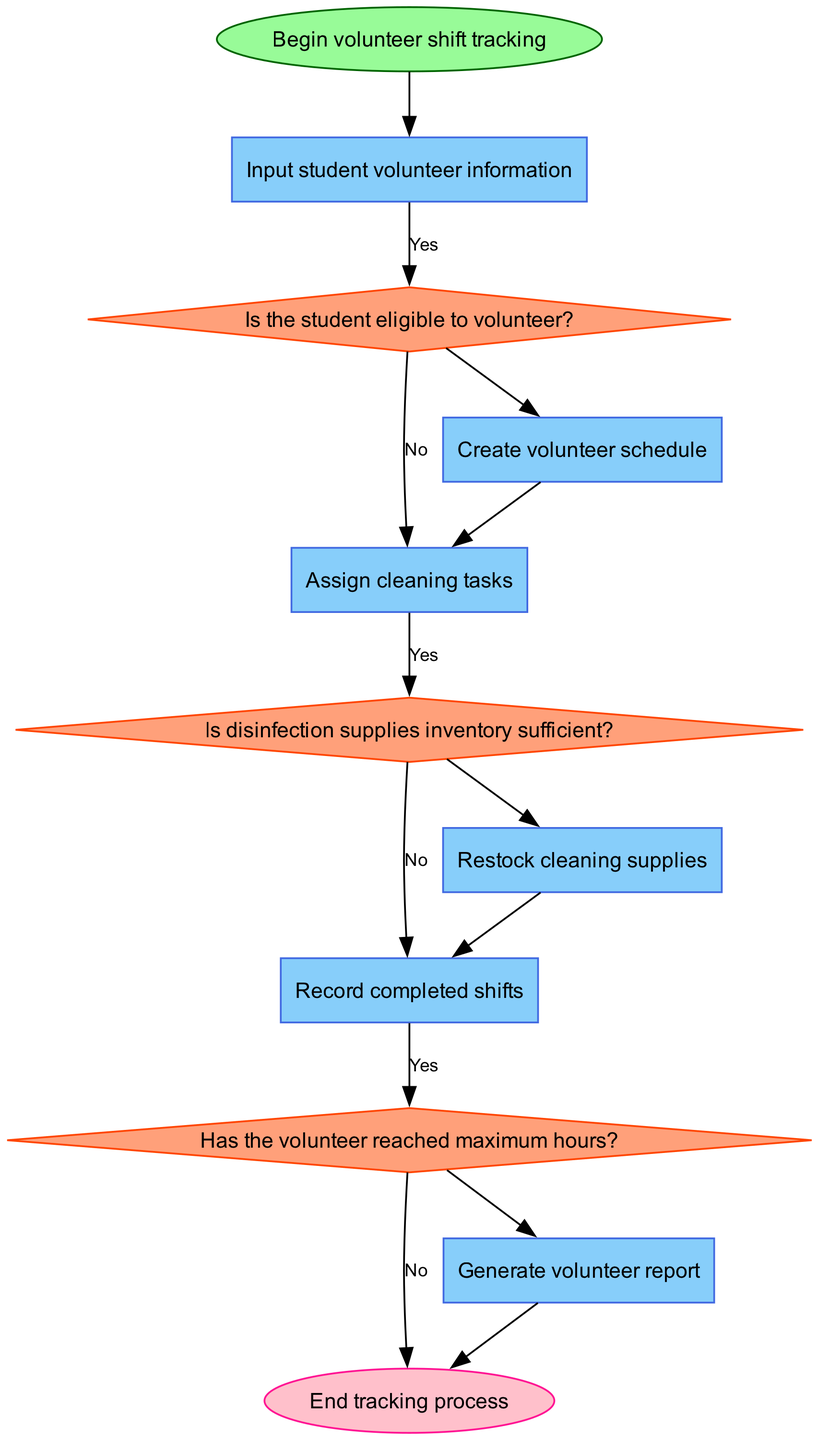What is the first step in the flowchart? The flowchart begins with the node labeled "Begin volunteer shift tracking." This is the starting point of the process, which is indicated in the flowchart.
Answer: Begin volunteer shift tracking How many decision nodes are in the flowchart? There are three decision nodes in the flowchart. They are: "Is the student eligible to volunteer?", "Is disinfection supplies inventory sufficient?", and "Has the volunteer reached maximum hours?" Each decision point evaluates a condition before the process continues.
Answer: 3 What happens if a student is not eligible to volunteer? If a student is not eligible to volunteer, the flowchart does not specify further actions or outcomes, but it implies that the volunteer schedule would not be created for that student. This indicates that the process would not proceed for ineligible volunteers.
Answer: No schedule created What is recorded after cleaning tasks are assigned? After cleaning tasks are assigned, the next process in the flowchart is "Record completed shifts." This step ensures that the participation of volunteers is documented after they finish their cleaning assignments.
Answer: Record completed shifts Which process occurs if cleaning supplies need to be restocked? If the inventory of disinfection supplies is insufficient, the flowchart leads to the "Restock cleaning supplies" process. This means that before tasks are assigned, there is a check on supplies, and if they are low, they will be replenished.
Answer: Restock cleaning supplies What is the final step in the flowchart? The final step in the flowchart is labeled "End tracking process." This indicates that the entire volunteer shift tracking procedure concludes here after all previous steps have been completed.
Answer: End tracking process At which point is the volunteer report generated? The volunteer report is generated after recording completed shifts and only when the volunteer has reached maximum hours. If the maximum hours are not reached, the flowchart does not indicate a report generation.
Answer: Generate volunteer report If cleaning assignments are assigned, is supply restocking required? If cleaning assignments are assigned without sufficient supplies, the flowchart checks the inventory status with the question "Is disinfection supplies inventory sufficient?" If supplies are insufficient, restocking will occur before assignments are made.
Answer: Yes, if insufficient supplies 